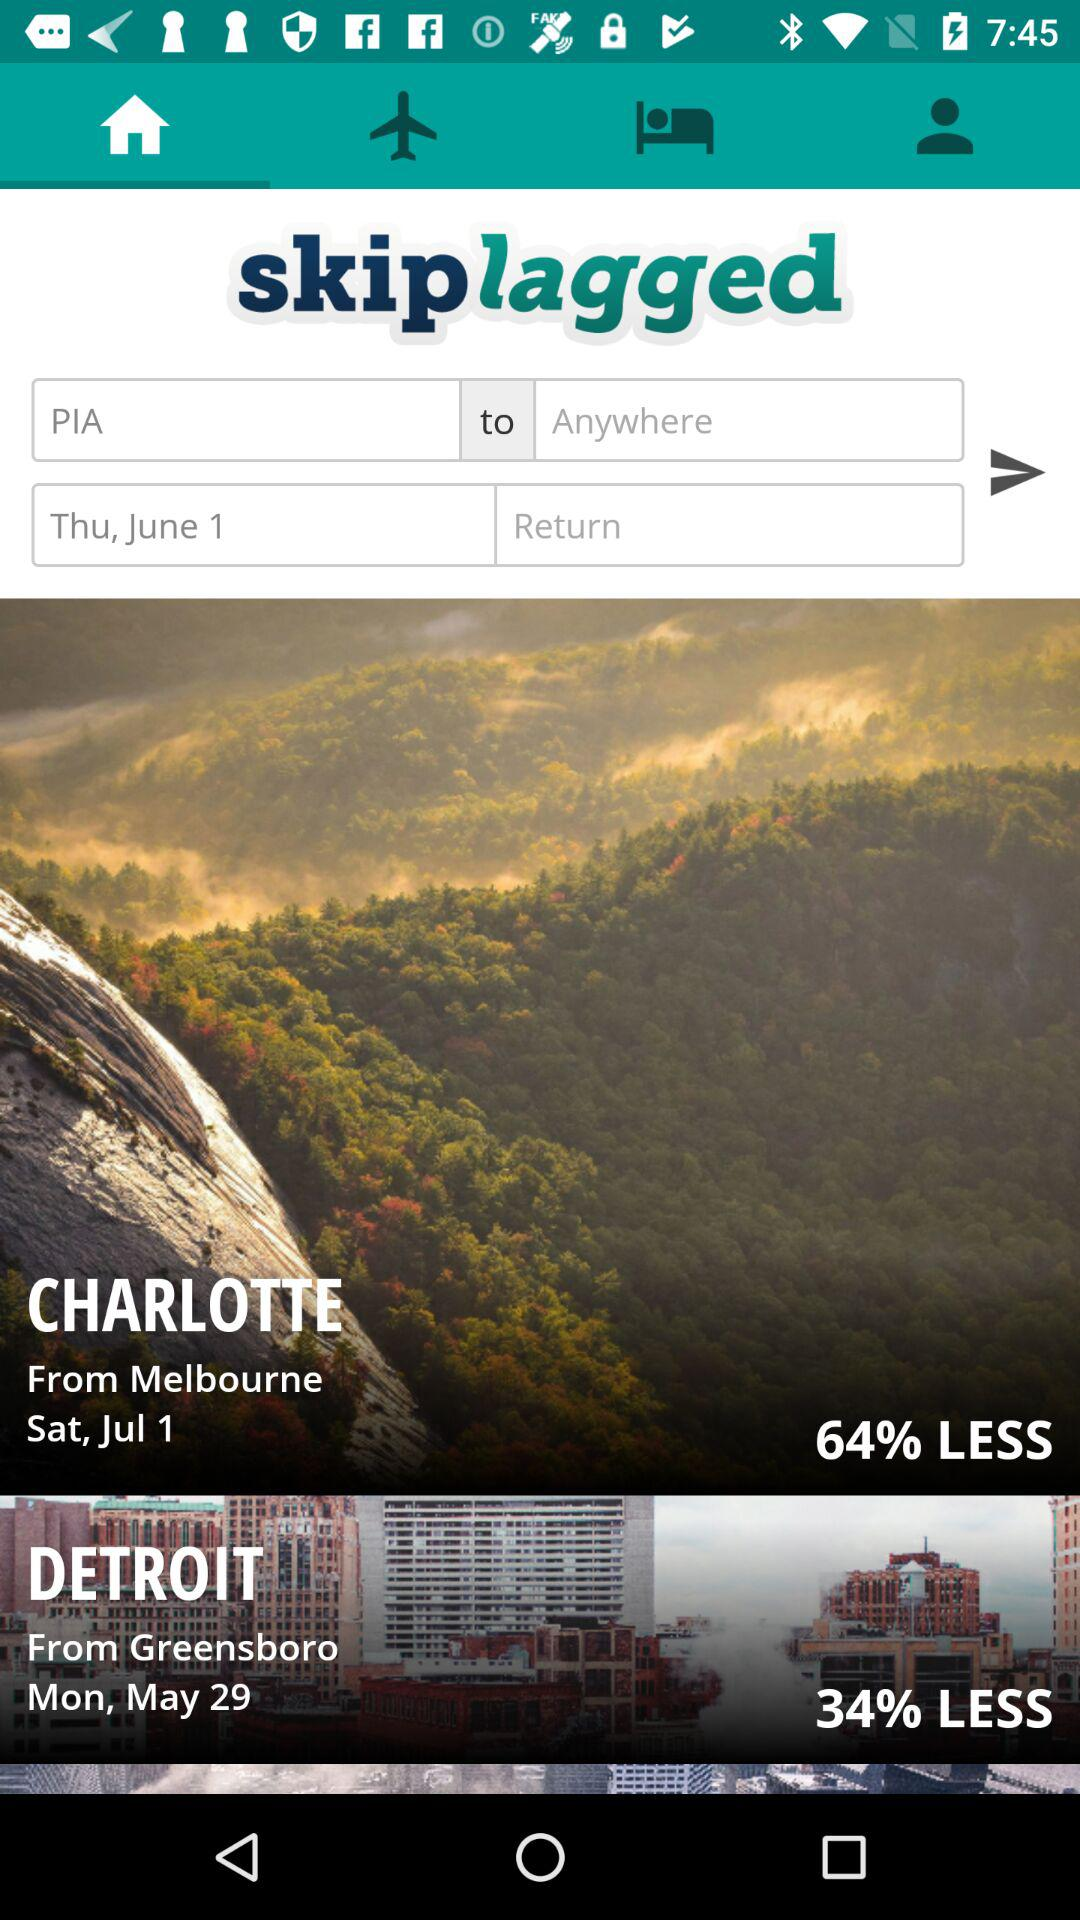Where is the flight from PIA going to?
When the provided information is insufficient, respond with <no answer>. <no answer> 